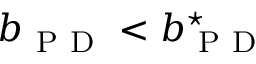Convert formula to latex. <formula><loc_0><loc_0><loc_500><loc_500>b _ { P D } < b _ { P D } ^ { ^ { * } }</formula> 